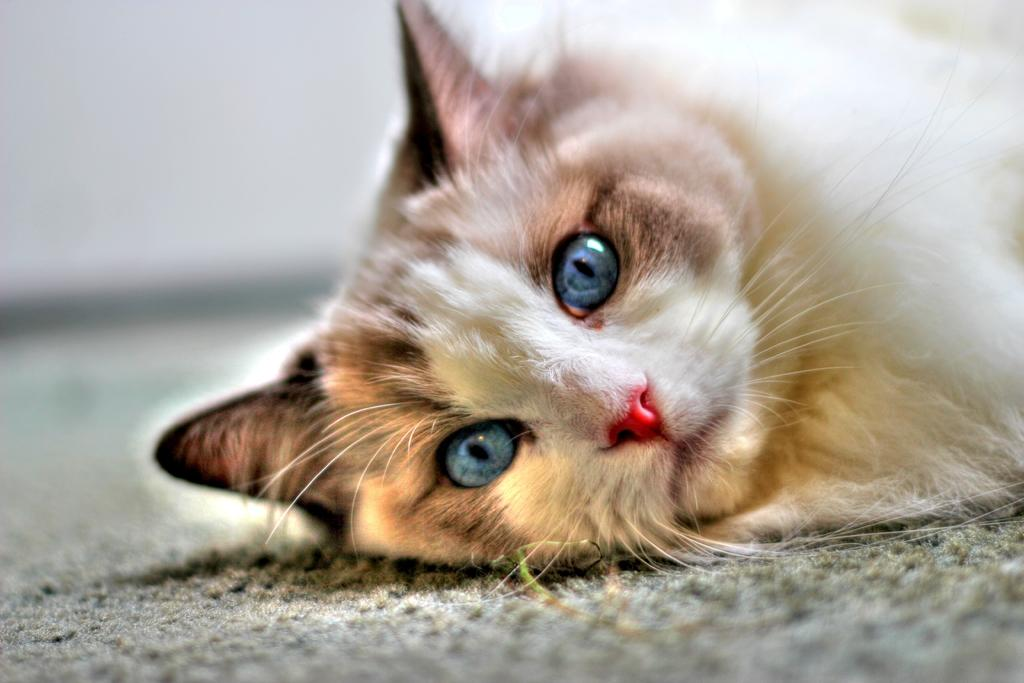What type of animal is in the image? There is a cat in the image. What is the cat doing in the image? The cat is lying on the floor. Can you describe the background of the image? The background of the image is blurred. Can you tell me how many times the cat jumps into the river in the image? There is no river present in the image, and the cat is not jumping. What type of animal is swimming in the river in the image? There is no river or swimming animal present in the image. 